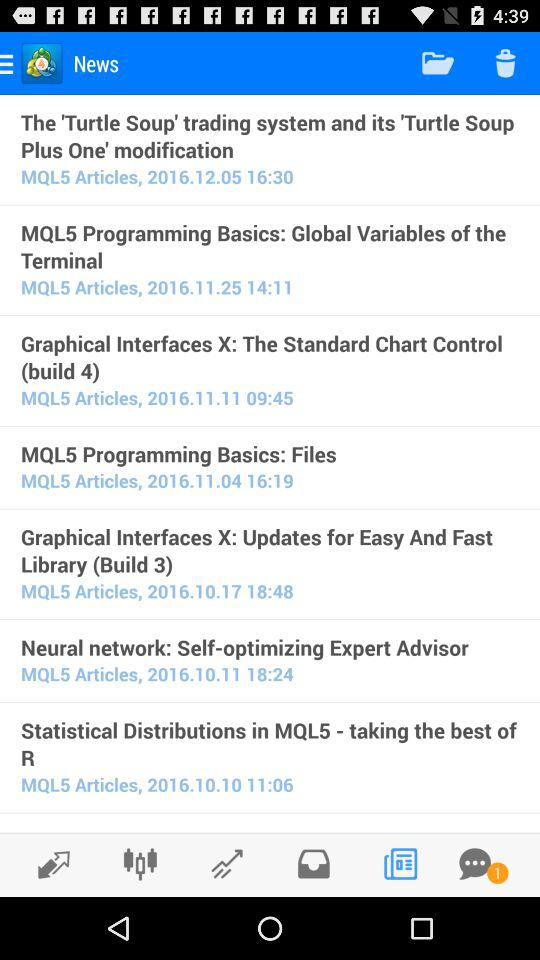When was the news about the 'Turtle Soup' trading system posted? The news about the 'Turtle Soup' trading system was posted on December 5, 2016 at 16:30. 